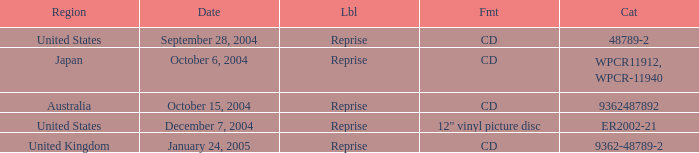What is the catalogue on october 15, 2004? 9362487892.0. 